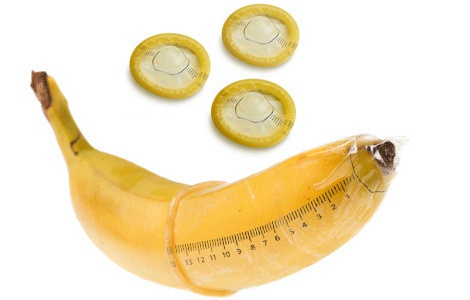Describe the objects in this image and their specific colors. I can see a banana in white, gold, orange, and tan tones in this image. 